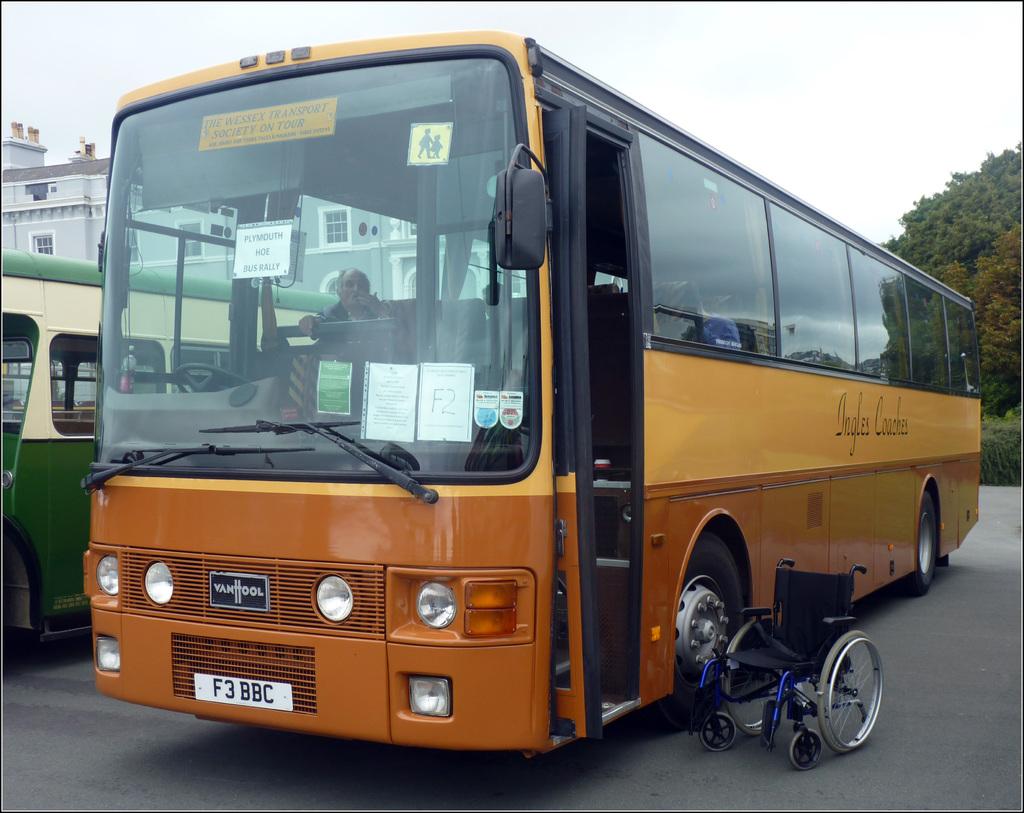What is on the front license plate of this bus?
Your response must be concise. F3 bbc. What is the brand of this bus?
Offer a terse response. Vanhool. 